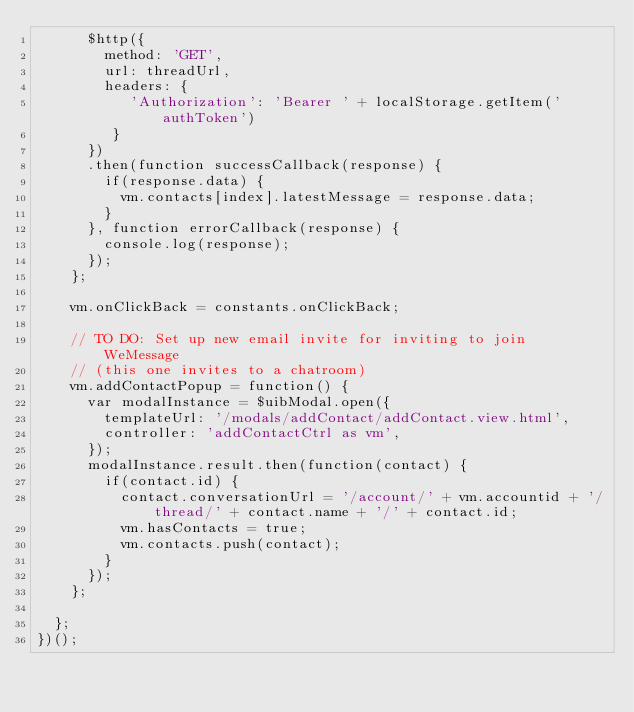<code> <loc_0><loc_0><loc_500><loc_500><_JavaScript_>      $http({
        method: 'GET',
        url: threadUrl,
        headers: {
           'Authorization': 'Bearer ' + localStorage.getItem('authToken')
         }
      })
      .then(function successCallback(response) {
        if(response.data) {
          vm.contacts[index].latestMessage = response.data;
        }
      }, function errorCallback(response) {
        console.log(response);
      });
    };

    vm.onClickBack = constants.onClickBack;

    // TO DO: Set up new email invite for inviting to join WeMessage
    // (this one invites to a chatroom)
    vm.addContactPopup = function() {
      var modalInstance = $uibModal.open({
        templateUrl: '/modals/addContact/addContact.view.html',
        controller: 'addContactCtrl as vm',
      });
      modalInstance.result.then(function(contact) {
        if(contact.id) {
          contact.conversationUrl = '/account/' + vm.accountid + '/thread/' + contact.name + '/' + contact.id;
          vm.hasContacts = true;
          vm.contacts.push(contact);
        }
      });
    };

  };
})();
</code> 